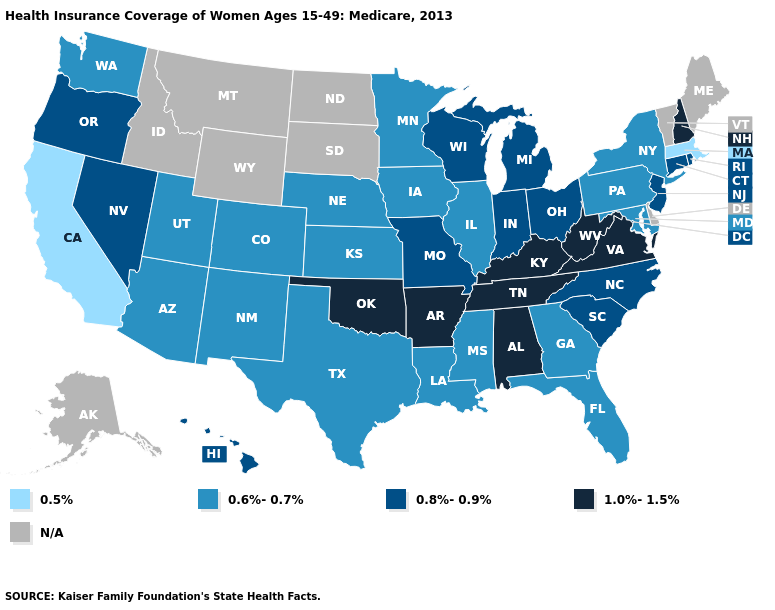Name the states that have a value in the range 0.8%-0.9%?
Concise answer only. Connecticut, Hawaii, Indiana, Michigan, Missouri, Nevada, New Jersey, North Carolina, Ohio, Oregon, Rhode Island, South Carolina, Wisconsin. Which states have the highest value in the USA?
Quick response, please. Alabama, Arkansas, Kentucky, New Hampshire, Oklahoma, Tennessee, Virginia, West Virginia. How many symbols are there in the legend?
Short answer required. 5. Which states have the lowest value in the USA?
Keep it brief. California, Massachusetts. Which states have the lowest value in the MidWest?
Concise answer only. Illinois, Iowa, Kansas, Minnesota, Nebraska. Does Massachusetts have the lowest value in the USA?
Be succinct. Yes. Which states have the lowest value in the USA?
Write a very short answer. California, Massachusetts. What is the highest value in the South ?
Be succinct. 1.0%-1.5%. What is the value of Louisiana?
Short answer required. 0.6%-0.7%. What is the value of Arizona?
Short answer required. 0.6%-0.7%. What is the value of Maryland?
Short answer required. 0.6%-0.7%. What is the value of North Dakota?
Write a very short answer. N/A. Among the states that border New York , does New Jersey have the highest value?
Give a very brief answer. Yes. What is the highest value in the MidWest ?
Answer briefly. 0.8%-0.9%. 